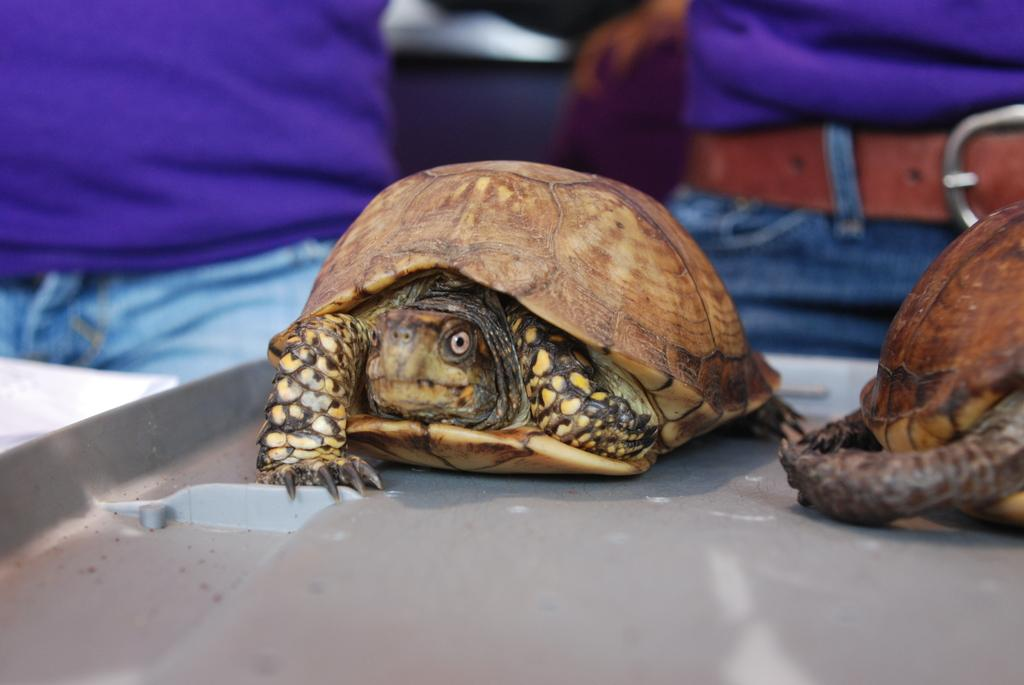What animals are in the front of the image? There are two turtles in the front of the image. What can be seen in the background of the image? There are two persons in the background of the image. Can you describe the clothing or accessories of one of the persons in the background? One person in the background is wearing a belt. What type of fowl can be seen interacting with the turtles in the image? There is no fowl present in the image; it only features two turtles and two persons in the background. What reason might the person in the background have for wearing a yak on their head? There is no yak present in the image, and the person in the background is not wearing one on their head. 